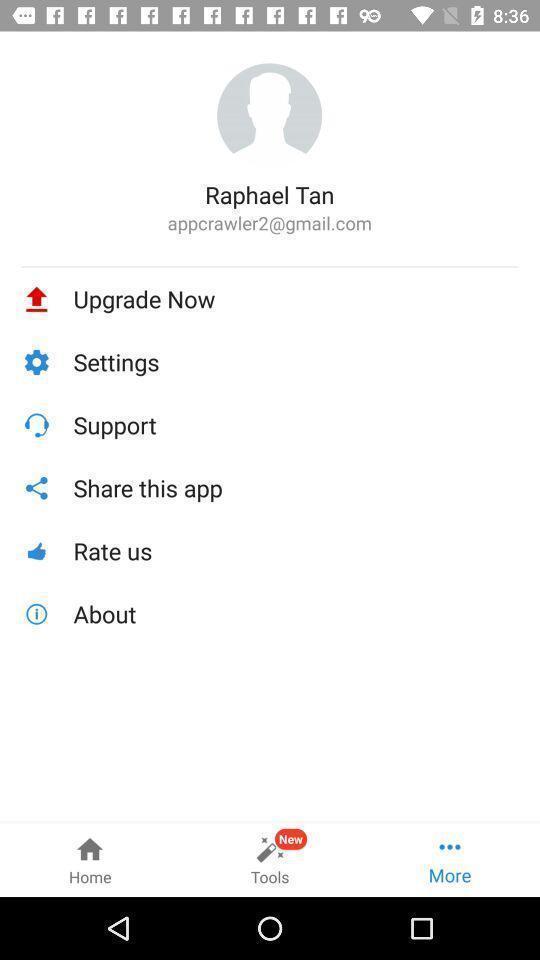Give me a summary of this screen capture. Screen shows on upgrading a profile. 